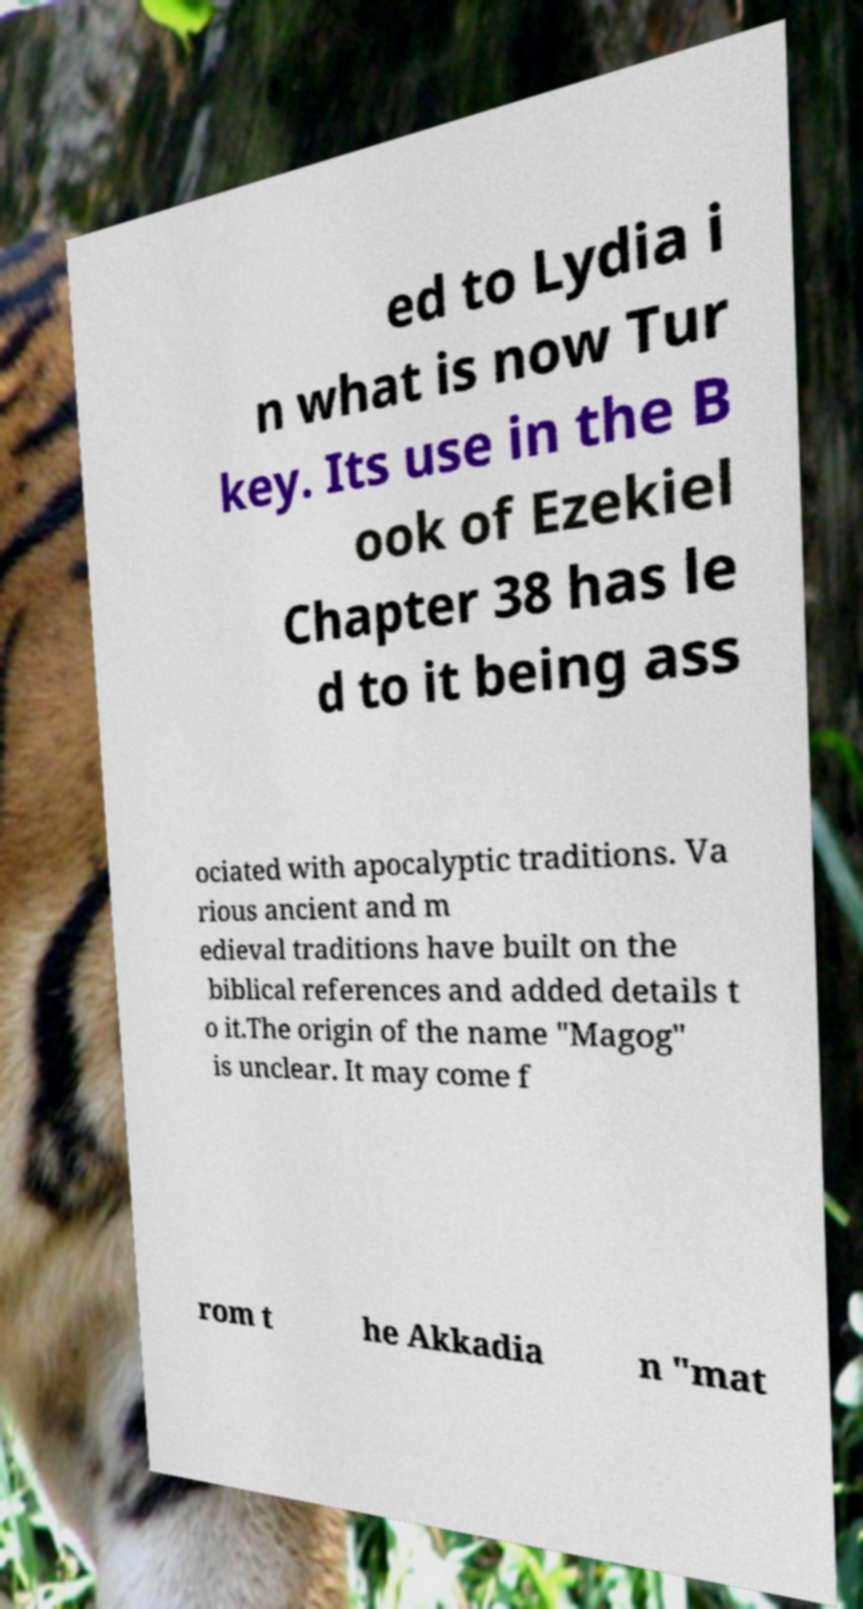Could you extract and type out the text from this image? ed to Lydia i n what is now Tur key. Its use in the B ook of Ezekiel Chapter 38 has le d to it being ass ociated with apocalyptic traditions. Va rious ancient and m edieval traditions have built on the biblical references and added details t o it.The origin of the name "Magog" is unclear. It may come f rom t he Akkadia n "mat 